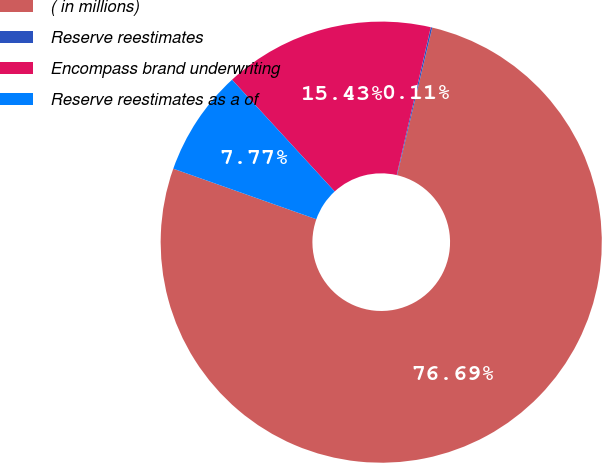<chart> <loc_0><loc_0><loc_500><loc_500><pie_chart><fcel>( in millions)<fcel>Reserve reestimates<fcel>Encompass brand underwriting<fcel>Reserve reestimates as a of<nl><fcel>76.69%<fcel>0.11%<fcel>15.43%<fcel>7.77%<nl></chart> 